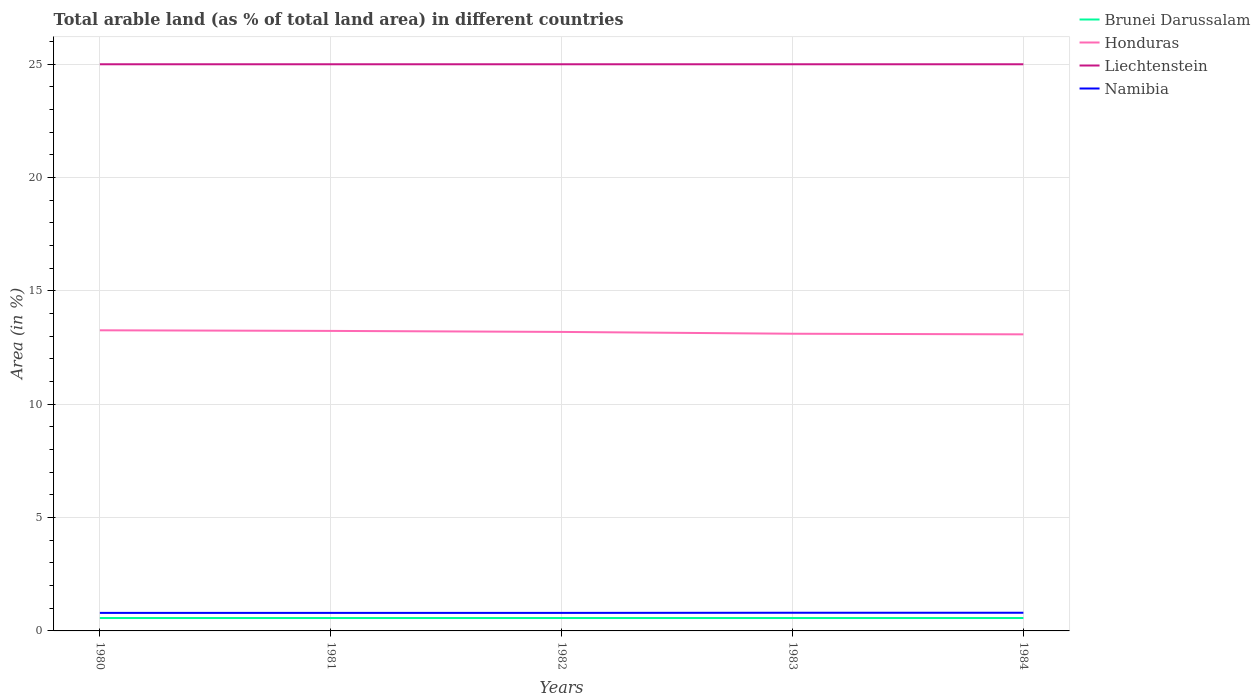How many different coloured lines are there?
Provide a succinct answer. 4. Is the number of lines equal to the number of legend labels?
Keep it short and to the point. Yes. Across all years, what is the maximum percentage of arable land in Brunei Darussalam?
Provide a succinct answer. 0.57. In which year was the percentage of arable land in Honduras maximum?
Offer a very short reply. 1984. What is the total percentage of arable land in Liechtenstein in the graph?
Your response must be concise. 0. What is the difference between the highest and the second highest percentage of arable land in Namibia?
Keep it short and to the point. 0.01. Is the percentage of arable land in Namibia strictly greater than the percentage of arable land in Brunei Darussalam over the years?
Ensure brevity in your answer.  No. How many lines are there?
Give a very brief answer. 4. How many years are there in the graph?
Give a very brief answer. 5. What is the difference between two consecutive major ticks on the Y-axis?
Offer a very short reply. 5. Does the graph contain grids?
Make the answer very short. Yes. How many legend labels are there?
Provide a short and direct response. 4. What is the title of the graph?
Your answer should be very brief. Total arable land (as % of total land area) in different countries. Does "Isle of Man" appear as one of the legend labels in the graph?
Your response must be concise. No. What is the label or title of the X-axis?
Ensure brevity in your answer.  Years. What is the label or title of the Y-axis?
Your answer should be very brief. Area (in %). What is the Area (in %) in Brunei Darussalam in 1980?
Offer a terse response. 0.57. What is the Area (in %) of Honduras in 1980?
Provide a succinct answer. 13.26. What is the Area (in %) of Namibia in 1980?
Offer a terse response. 0.8. What is the Area (in %) in Brunei Darussalam in 1981?
Make the answer very short. 0.57. What is the Area (in %) of Honduras in 1981?
Make the answer very short. 13.24. What is the Area (in %) in Namibia in 1981?
Make the answer very short. 0.8. What is the Area (in %) of Brunei Darussalam in 1982?
Your answer should be very brief. 0.57. What is the Area (in %) in Honduras in 1982?
Your response must be concise. 13.19. What is the Area (in %) in Liechtenstein in 1982?
Offer a terse response. 25. What is the Area (in %) of Namibia in 1982?
Offer a very short reply. 0.8. What is the Area (in %) in Brunei Darussalam in 1983?
Keep it short and to the point. 0.57. What is the Area (in %) in Honduras in 1983?
Provide a short and direct response. 13.11. What is the Area (in %) in Namibia in 1983?
Give a very brief answer. 0.8. What is the Area (in %) in Brunei Darussalam in 1984?
Your answer should be compact. 0.57. What is the Area (in %) in Honduras in 1984?
Ensure brevity in your answer.  13.08. What is the Area (in %) in Namibia in 1984?
Make the answer very short. 0.8. Across all years, what is the maximum Area (in %) of Brunei Darussalam?
Make the answer very short. 0.57. Across all years, what is the maximum Area (in %) in Honduras?
Keep it short and to the point. 13.26. Across all years, what is the maximum Area (in %) in Liechtenstein?
Give a very brief answer. 25. Across all years, what is the maximum Area (in %) of Namibia?
Give a very brief answer. 0.8. Across all years, what is the minimum Area (in %) in Brunei Darussalam?
Provide a short and direct response. 0.57. Across all years, what is the minimum Area (in %) of Honduras?
Keep it short and to the point. 13.08. Across all years, what is the minimum Area (in %) of Namibia?
Offer a very short reply. 0.8. What is the total Area (in %) of Brunei Darussalam in the graph?
Your answer should be compact. 2.85. What is the total Area (in %) in Honduras in the graph?
Your answer should be compact. 65.89. What is the total Area (in %) in Liechtenstein in the graph?
Provide a succinct answer. 125. What is the total Area (in %) of Namibia in the graph?
Offer a terse response. 3.99. What is the difference between the Area (in %) of Honduras in 1980 and that in 1981?
Offer a very short reply. 0.03. What is the difference between the Area (in %) in Namibia in 1980 and that in 1981?
Your response must be concise. 0. What is the difference between the Area (in %) of Honduras in 1980 and that in 1982?
Offer a very short reply. 0.07. What is the difference between the Area (in %) in Namibia in 1980 and that in 1982?
Your answer should be very brief. 0. What is the difference between the Area (in %) of Honduras in 1980 and that in 1983?
Keep it short and to the point. 0.15. What is the difference between the Area (in %) of Namibia in 1980 and that in 1983?
Provide a succinct answer. -0.01. What is the difference between the Area (in %) of Honduras in 1980 and that in 1984?
Your answer should be very brief. 0.18. What is the difference between the Area (in %) in Namibia in 1980 and that in 1984?
Ensure brevity in your answer.  -0.01. What is the difference between the Area (in %) of Honduras in 1981 and that in 1982?
Give a very brief answer. 0.04. What is the difference between the Area (in %) of Honduras in 1981 and that in 1983?
Your answer should be very brief. 0.13. What is the difference between the Area (in %) of Namibia in 1981 and that in 1983?
Offer a terse response. -0.01. What is the difference between the Area (in %) of Brunei Darussalam in 1981 and that in 1984?
Offer a terse response. 0. What is the difference between the Area (in %) in Honduras in 1981 and that in 1984?
Your answer should be compact. 0.15. What is the difference between the Area (in %) of Liechtenstein in 1981 and that in 1984?
Your answer should be very brief. 0. What is the difference between the Area (in %) of Namibia in 1981 and that in 1984?
Make the answer very short. -0.01. What is the difference between the Area (in %) of Honduras in 1982 and that in 1983?
Provide a succinct answer. 0.08. What is the difference between the Area (in %) in Namibia in 1982 and that in 1983?
Ensure brevity in your answer.  -0.01. What is the difference between the Area (in %) of Brunei Darussalam in 1982 and that in 1984?
Offer a terse response. 0. What is the difference between the Area (in %) in Honduras in 1982 and that in 1984?
Offer a very short reply. 0.11. What is the difference between the Area (in %) of Liechtenstein in 1982 and that in 1984?
Offer a very short reply. 0. What is the difference between the Area (in %) of Namibia in 1982 and that in 1984?
Provide a succinct answer. -0.01. What is the difference between the Area (in %) of Brunei Darussalam in 1983 and that in 1984?
Offer a terse response. 0. What is the difference between the Area (in %) in Honduras in 1983 and that in 1984?
Your response must be concise. 0.03. What is the difference between the Area (in %) in Liechtenstein in 1983 and that in 1984?
Offer a very short reply. 0. What is the difference between the Area (in %) of Namibia in 1983 and that in 1984?
Make the answer very short. 0. What is the difference between the Area (in %) of Brunei Darussalam in 1980 and the Area (in %) of Honduras in 1981?
Provide a short and direct response. -12.67. What is the difference between the Area (in %) in Brunei Darussalam in 1980 and the Area (in %) in Liechtenstein in 1981?
Give a very brief answer. -24.43. What is the difference between the Area (in %) of Brunei Darussalam in 1980 and the Area (in %) of Namibia in 1981?
Offer a terse response. -0.23. What is the difference between the Area (in %) of Honduras in 1980 and the Area (in %) of Liechtenstein in 1981?
Give a very brief answer. -11.74. What is the difference between the Area (in %) of Honduras in 1980 and the Area (in %) of Namibia in 1981?
Your response must be concise. 12.47. What is the difference between the Area (in %) in Liechtenstein in 1980 and the Area (in %) in Namibia in 1981?
Your answer should be compact. 24.2. What is the difference between the Area (in %) in Brunei Darussalam in 1980 and the Area (in %) in Honduras in 1982?
Keep it short and to the point. -12.62. What is the difference between the Area (in %) in Brunei Darussalam in 1980 and the Area (in %) in Liechtenstein in 1982?
Provide a short and direct response. -24.43. What is the difference between the Area (in %) of Brunei Darussalam in 1980 and the Area (in %) of Namibia in 1982?
Give a very brief answer. -0.23. What is the difference between the Area (in %) of Honduras in 1980 and the Area (in %) of Liechtenstein in 1982?
Your answer should be compact. -11.74. What is the difference between the Area (in %) in Honduras in 1980 and the Area (in %) in Namibia in 1982?
Your answer should be very brief. 12.47. What is the difference between the Area (in %) in Liechtenstein in 1980 and the Area (in %) in Namibia in 1982?
Your answer should be very brief. 24.2. What is the difference between the Area (in %) of Brunei Darussalam in 1980 and the Area (in %) of Honduras in 1983?
Offer a very short reply. -12.54. What is the difference between the Area (in %) of Brunei Darussalam in 1980 and the Area (in %) of Liechtenstein in 1983?
Give a very brief answer. -24.43. What is the difference between the Area (in %) in Brunei Darussalam in 1980 and the Area (in %) in Namibia in 1983?
Give a very brief answer. -0.23. What is the difference between the Area (in %) in Honduras in 1980 and the Area (in %) in Liechtenstein in 1983?
Provide a succinct answer. -11.74. What is the difference between the Area (in %) of Honduras in 1980 and the Area (in %) of Namibia in 1983?
Your response must be concise. 12.46. What is the difference between the Area (in %) in Liechtenstein in 1980 and the Area (in %) in Namibia in 1983?
Offer a terse response. 24.2. What is the difference between the Area (in %) in Brunei Darussalam in 1980 and the Area (in %) in Honduras in 1984?
Your answer should be very brief. -12.52. What is the difference between the Area (in %) of Brunei Darussalam in 1980 and the Area (in %) of Liechtenstein in 1984?
Your answer should be very brief. -24.43. What is the difference between the Area (in %) in Brunei Darussalam in 1980 and the Area (in %) in Namibia in 1984?
Provide a succinct answer. -0.23. What is the difference between the Area (in %) in Honduras in 1980 and the Area (in %) in Liechtenstein in 1984?
Ensure brevity in your answer.  -11.74. What is the difference between the Area (in %) in Honduras in 1980 and the Area (in %) in Namibia in 1984?
Give a very brief answer. 12.46. What is the difference between the Area (in %) of Liechtenstein in 1980 and the Area (in %) of Namibia in 1984?
Provide a succinct answer. 24.2. What is the difference between the Area (in %) of Brunei Darussalam in 1981 and the Area (in %) of Honduras in 1982?
Make the answer very short. -12.62. What is the difference between the Area (in %) of Brunei Darussalam in 1981 and the Area (in %) of Liechtenstein in 1982?
Your answer should be compact. -24.43. What is the difference between the Area (in %) of Brunei Darussalam in 1981 and the Area (in %) of Namibia in 1982?
Keep it short and to the point. -0.23. What is the difference between the Area (in %) in Honduras in 1981 and the Area (in %) in Liechtenstein in 1982?
Your answer should be compact. -11.76. What is the difference between the Area (in %) of Honduras in 1981 and the Area (in %) of Namibia in 1982?
Keep it short and to the point. 12.44. What is the difference between the Area (in %) of Liechtenstein in 1981 and the Area (in %) of Namibia in 1982?
Provide a short and direct response. 24.2. What is the difference between the Area (in %) of Brunei Darussalam in 1981 and the Area (in %) of Honduras in 1983?
Provide a short and direct response. -12.54. What is the difference between the Area (in %) of Brunei Darussalam in 1981 and the Area (in %) of Liechtenstein in 1983?
Your answer should be very brief. -24.43. What is the difference between the Area (in %) of Brunei Darussalam in 1981 and the Area (in %) of Namibia in 1983?
Keep it short and to the point. -0.23. What is the difference between the Area (in %) in Honduras in 1981 and the Area (in %) in Liechtenstein in 1983?
Offer a terse response. -11.76. What is the difference between the Area (in %) in Honduras in 1981 and the Area (in %) in Namibia in 1983?
Your response must be concise. 12.43. What is the difference between the Area (in %) in Liechtenstein in 1981 and the Area (in %) in Namibia in 1983?
Your answer should be compact. 24.2. What is the difference between the Area (in %) of Brunei Darussalam in 1981 and the Area (in %) of Honduras in 1984?
Your answer should be compact. -12.52. What is the difference between the Area (in %) in Brunei Darussalam in 1981 and the Area (in %) in Liechtenstein in 1984?
Make the answer very short. -24.43. What is the difference between the Area (in %) in Brunei Darussalam in 1981 and the Area (in %) in Namibia in 1984?
Ensure brevity in your answer.  -0.23. What is the difference between the Area (in %) in Honduras in 1981 and the Area (in %) in Liechtenstein in 1984?
Your answer should be very brief. -11.76. What is the difference between the Area (in %) of Honduras in 1981 and the Area (in %) of Namibia in 1984?
Your response must be concise. 12.43. What is the difference between the Area (in %) of Liechtenstein in 1981 and the Area (in %) of Namibia in 1984?
Make the answer very short. 24.2. What is the difference between the Area (in %) of Brunei Darussalam in 1982 and the Area (in %) of Honduras in 1983?
Your response must be concise. -12.54. What is the difference between the Area (in %) in Brunei Darussalam in 1982 and the Area (in %) in Liechtenstein in 1983?
Offer a very short reply. -24.43. What is the difference between the Area (in %) in Brunei Darussalam in 1982 and the Area (in %) in Namibia in 1983?
Make the answer very short. -0.23. What is the difference between the Area (in %) in Honduras in 1982 and the Area (in %) in Liechtenstein in 1983?
Offer a very short reply. -11.81. What is the difference between the Area (in %) in Honduras in 1982 and the Area (in %) in Namibia in 1983?
Provide a succinct answer. 12.39. What is the difference between the Area (in %) in Liechtenstein in 1982 and the Area (in %) in Namibia in 1983?
Your answer should be compact. 24.2. What is the difference between the Area (in %) of Brunei Darussalam in 1982 and the Area (in %) of Honduras in 1984?
Offer a very short reply. -12.52. What is the difference between the Area (in %) in Brunei Darussalam in 1982 and the Area (in %) in Liechtenstein in 1984?
Offer a terse response. -24.43. What is the difference between the Area (in %) in Brunei Darussalam in 1982 and the Area (in %) in Namibia in 1984?
Offer a terse response. -0.23. What is the difference between the Area (in %) in Honduras in 1982 and the Area (in %) in Liechtenstein in 1984?
Ensure brevity in your answer.  -11.81. What is the difference between the Area (in %) of Honduras in 1982 and the Area (in %) of Namibia in 1984?
Provide a short and direct response. 12.39. What is the difference between the Area (in %) in Liechtenstein in 1982 and the Area (in %) in Namibia in 1984?
Give a very brief answer. 24.2. What is the difference between the Area (in %) in Brunei Darussalam in 1983 and the Area (in %) in Honduras in 1984?
Your answer should be very brief. -12.52. What is the difference between the Area (in %) in Brunei Darussalam in 1983 and the Area (in %) in Liechtenstein in 1984?
Keep it short and to the point. -24.43. What is the difference between the Area (in %) in Brunei Darussalam in 1983 and the Area (in %) in Namibia in 1984?
Offer a very short reply. -0.23. What is the difference between the Area (in %) in Honduras in 1983 and the Area (in %) in Liechtenstein in 1984?
Offer a terse response. -11.89. What is the difference between the Area (in %) of Honduras in 1983 and the Area (in %) of Namibia in 1984?
Provide a short and direct response. 12.31. What is the difference between the Area (in %) in Liechtenstein in 1983 and the Area (in %) in Namibia in 1984?
Make the answer very short. 24.2. What is the average Area (in %) of Brunei Darussalam per year?
Keep it short and to the point. 0.57. What is the average Area (in %) of Honduras per year?
Your answer should be very brief. 13.18. What is the average Area (in %) of Liechtenstein per year?
Offer a terse response. 25. What is the average Area (in %) of Namibia per year?
Offer a terse response. 0.8. In the year 1980, what is the difference between the Area (in %) in Brunei Darussalam and Area (in %) in Honduras?
Keep it short and to the point. -12.69. In the year 1980, what is the difference between the Area (in %) in Brunei Darussalam and Area (in %) in Liechtenstein?
Offer a very short reply. -24.43. In the year 1980, what is the difference between the Area (in %) of Brunei Darussalam and Area (in %) of Namibia?
Provide a short and direct response. -0.23. In the year 1980, what is the difference between the Area (in %) in Honduras and Area (in %) in Liechtenstein?
Provide a succinct answer. -11.74. In the year 1980, what is the difference between the Area (in %) in Honduras and Area (in %) in Namibia?
Your answer should be very brief. 12.47. In the year 1980, what is the difference between the Area (in %) in Liechtenstein and Area (in %) in Namibia?
Ensure brevity in your answer.  24.2. In the year 1981, what is the difference between the Area (in %) in Brunei Darussalam and Area (in %) in Honduras?
Your response must be concise. -12.67. In the year 1981, what is the difference between the Area (in %) of Brunei Darussalam and Area (in %) of Liechtenstein?
Your answer should be very brief. -24.43. In the year 1981, what is the difference between the Area (in %) of Brunei Darussalam and Area (in %) of Namibia?
Give a very brief answer. -0.23. In the year 1981, what is the difference between the Area (in %) in Honduras and Area (in %) in Liechtenstein?
Ensure brevity in your answer.  -11.76. In the year 1981, what is the difference between the Area (in %) in Honduras and Area (in %) in Namibia?
Make the answer very short. 12.44. In the year 1981, what is the difference between the Area (in %) in Liechtenstein and Area (in %) in Namibia?
Ensure brevity in your answer.  24.2. In the year 1982, what is the difference between the Area (in %) of Brunei Darussalam and Area (in %) of Honduras?
Your answer should be very brief. -12.62. In the year 1982, what is the difference between the Area (in %) in Brunei Darussalam and Area (in %) in Liechtenstein?
Provide a succinct answer. -24.43. In the year 1982, what is the difference between the Area (in %) of Brunei Darussalam and Area (in %) of Namibia?
Your response must be concise. -0.23. In the year 1982, what is the difference between the Area (in %) of Honduras and Area (in %) of Liechtenstein?
Ensure brevity in your answer.  -11.81. In the year 1982, what is the difference between the Area (in %) of Honduras and Area (in %) of Namibia?
Ensure brevity in your answer.  12.4. In the year 1982, what is the difference between the Area (in %) in Liechtenstein and Area (in %) in Namibia?
Provide a short and direct response. 24.2. In the year 1983, what is the difference between the Area (in %) in Brunei Darussalam and Area (in %) in Honduras?
Provide a short and direct response. -12.54. In the year 1983, what is the difference between the Area (in %) of Brunei Darussalam and Area (in %) of Liechtenstein?
Ensure brevity in your answer.  -24.43. In the year 1983, what is the difference between the Area (in %) in Brunei Darussalam and Area (in %) in Namibia?
Ensure brevity in your answer.  -0.23. In the year 1983, what is the difference between the Area (in %) in Honduras and Area (in %) in Liechtenstein?
Make the answer very short. -11.89. In the year 1983, what is the difference between the Area (in %) of Honduras and Area (in %) of Namibia?
Your answer should be very brief. 12.31. In the year 1983, what is the difference between the Area (in %) in Liechtenstein and Area (in %) in Namibia?
Provide a succinct answer. 24.2. In the year 1984, what is the difference between the Area (in %) of Brunei Darussalam and Area (in %) of Honduras?
Make the answer very short. -12.52. In the year 1984, what is the difference between the Area (in %) of Brunei Darussalam and Area (in %) of Liechtenstein?
Your answer should be compact. -24.43. In the year 1984, what is the difference between the Area (in %) of Brunei Darussalam and Area (in %) of Namibia?
Make the answer very short. -0.23. In the year 1984, what is the difference between the Area (in %) of Honduras and Area (in %) of Liechtenstein?
Keep it short and to the point. -11.92. In the year 1984, what is the difference between the Area (in %) of Honduras and Area (in %) of Namibia?
Provide a short and direct response. 12.28. In the year 1984, what is the difference between the Area (in %) in Liechtenstein and Area (in %) in Namibia?
Offer a terse response. 24.2. What is the ratio of the Area (in %) in Honduras in 1980 to that in 1981?
Give a very brief answer. 1. What is the ratio of the Area (in %) of Honduras in 1980 to that in 1982?
Your answer should be very brief. 1.01. What is the ratio of the Area (in %) of Honduras in 1980 to that in 1983?
Offer a terse response. 1.01. What is the ratio of the Area (in %) of Brunei Darussalam in 1980 to that in 1984?
Offer a very short reply. 1. What is the ratio of the Area (in %) in Honduras in 1980 to that in 1984?
Give a very brief answer. 1.01. What is the ratio of the Area (in %) in Namibia in 1980 to that in 1984?
Your answer should be very brief. 0.99. What is the ratio of the Area (in %) of Honduras in 1981 to that in 1982?
Your answer should be very brief. 1. What is the ratio of the Area (in %) of Liechtenstein in 1981 to that in 1982?
Ensure brevity in your answer.  1. What is the ratio of the Area (in %) of Honduras in 1981 to that in 1983?
Provide a succinct answer. 1.01. What is the ratio of the Area (in %) of Liechtenstein in 1981 to that in 1983?
Your answer should be compact. 1. What is the ratio of the Area (in %) in Namibia in 1981 to that in 1983?
Make the answer very short. 0.99. What is the ratio of the Area (in %) in Brunei Darussalam in 1981 to that in 1984?
Offer a terse response. 1. What is the ratio of the Area (in %) in Honduras in 1981 to that in 1984?
Provide a succinct answer. 1.01. What is the ratio of the Area (in %) of Namibia in 1981 to that in 1984?
Offer a terse response. 0.99. What is the ratio of the Area (in %) in Liechtenstein in 1982 to that in 1983?
Provide a short and direct response. 1. What is the ratio of the Area (in %) in Honduras in 1982 to that in 1984?
Offer a terse response. 1.01. What is the ratio of the Area (in %) in Liechtenstein in 1982 to that in 1984?
Provide a short and direct response. 1. What is the ratio of the Area (in %) of Namibia in 1982 to that in 1984?
Your answer should be compact. 0.99. What is the ratio of the Area (in %) of Honduras in 1983 to that in 1984?
Your answer should be compact. 1. What is the difference between the highest and the second highest Area (in %) in Honduras?
Offer a very short reply. 0.03. What is the difference between the highest and the lowest Area (in %) in Honduras?
Your answer should be very brief. 0.18. What is the difference between the highest and the lowest Area (in %) of Namibia?
Your answer should be compact. 0.01. 